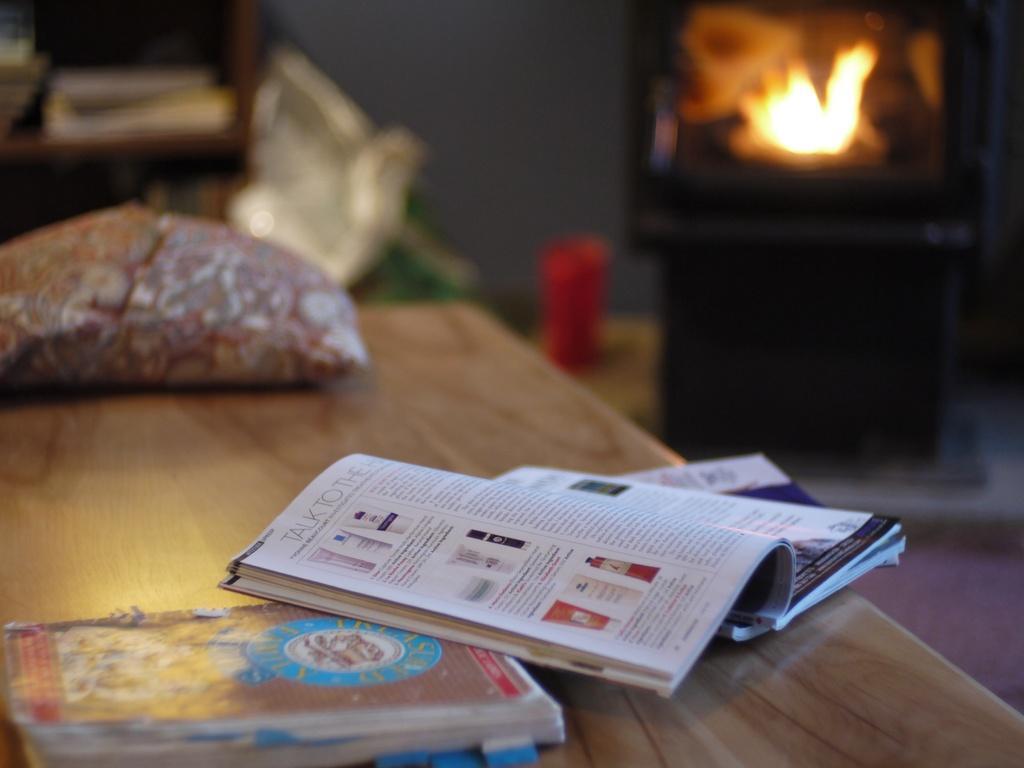Could you give a brief overview of what you see in this image? There are group of books on the table where one among them is kept opened. 